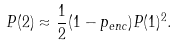Convert formula to latex. <formula><loc_0><loc_0><loc_500><loc_500>P ( 2 ) \approx \frac { 1 } { 2 } ( 1 - p _ { e n c } ) P ( 1 ) ^ { 2 } .</formula> 